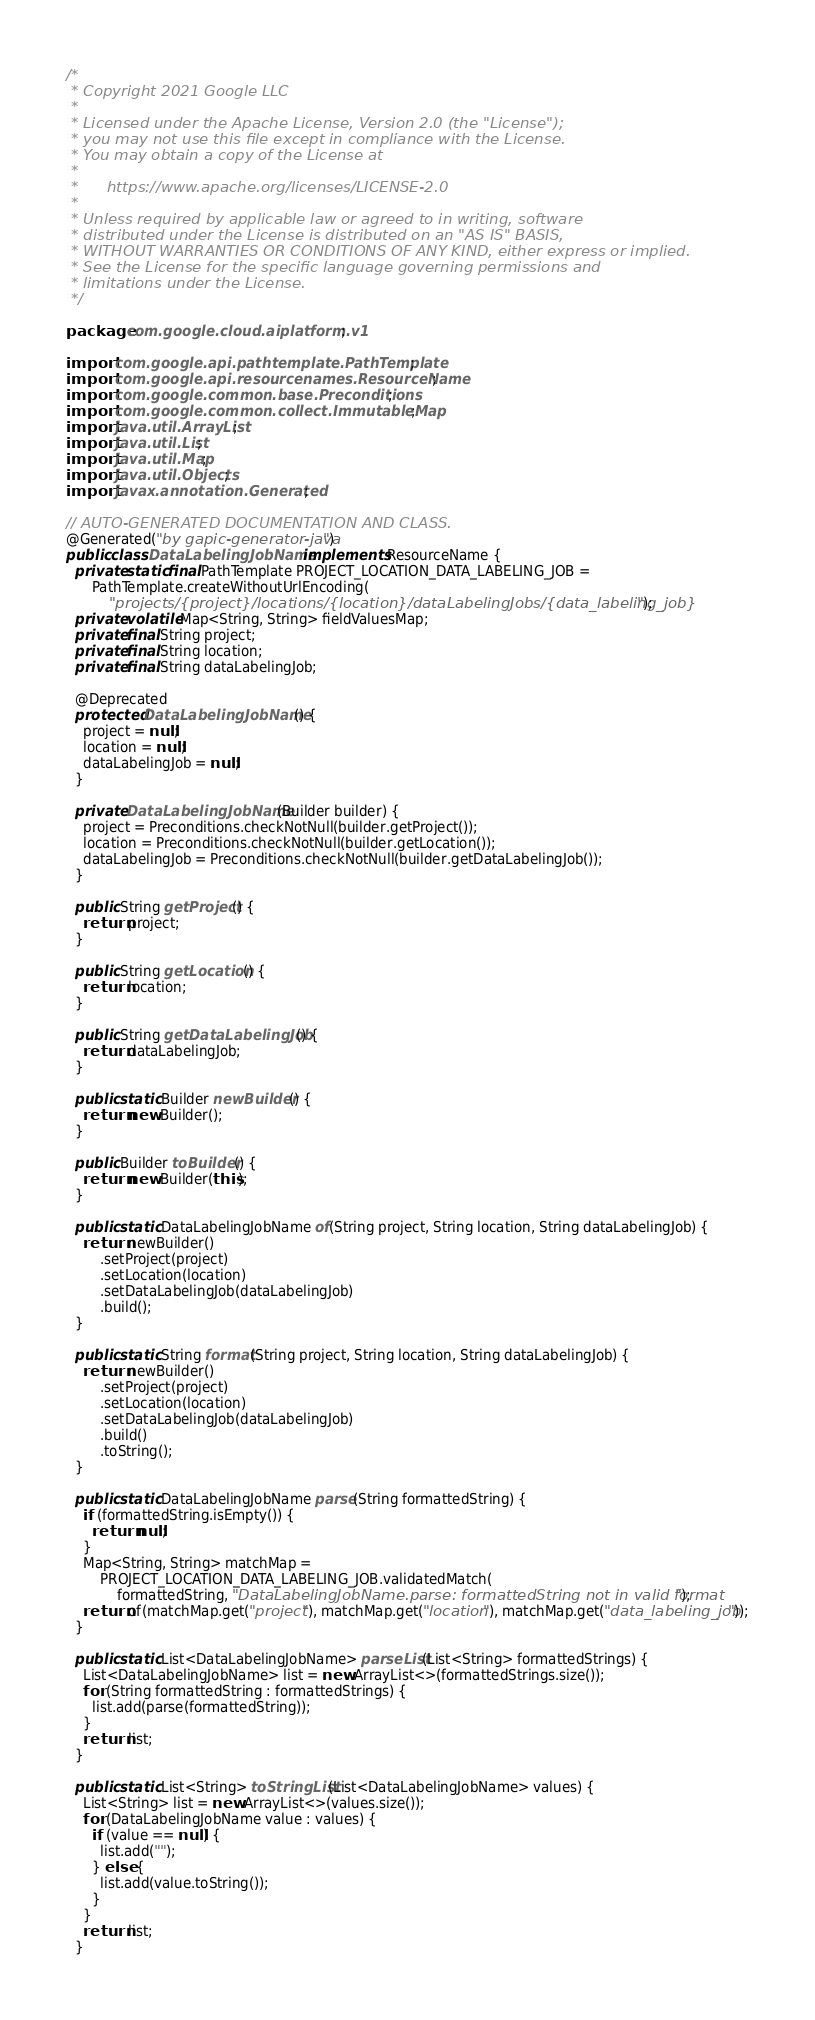Convert code to text. <code><loc_0><loc_0><loc_500><loc_500><_Java_>/*
 * Copyright 2021 Google LLC
 *
 * Licensed under the Apache License, Version 2.0 (the "License");
 * you may not use this file except in compliance with the License.
 * You may obtain a copy of the License at
 *
 *      https://www.apache.org/licenses/LICENSE-2.0
 *
 * Unless required by applicable law or agreed to in writing, software
 * distributed under the License is distributed on an "AS IS" BASIS,
 * WITHOUT WARRANTIES OR CONDITIONS OF ANY KIND, either express or implied.
 * See the License for the specific language governing permissions and
 * limitations under the License.
 */

package com.google.cloud.aiplatform.v1;

import com.google.api.pathtemplate.PathTemplate;
import com.google.api.resourcenames.ResourceName;
import com.google.common.base.Preconditions;
import com.google.common.collect.ImmutableMap;
import java.util.ArrayList;
import java.util.List;
import java.util.Map;
import java.util.Objects;
import javax.annotation.Generated;

// AUTO-GENERATED DOCUMENTATION AND CLASS.
@Generated("by gapic-generator-java")
public class DataLabelingJobName implements ResourceName {
  private static final PathTemplate PROJECT_LOCATION_DATA_LABELING_JOB =
      PathTemplate.createWithoutUrlEncoding(
          "projects/{project}/locations/{location}/dataLabelingJobs/{data_labeling_job}");
  private volatile Map<String, String> fieldValuesMap;
  private final String project;
  private final String location;
  private final String dataLabelingJob;

  @Deprecated
  protected DataLabelingJobName() {
    project = null;
    location = null;
    dataLabelingJob = null;
  }

  private DataLabelingJobName(Builder builder) {
    project = Preconditions.checkNotNull(builder.getProject());
    location = Preconditions.checkNotNull(builder.getLocation());
    dataLabelingJob = Preconditions.checkNotNull(builder.getDataLabelingJob());
  }

  public String getProject() {
    return project;
  }

  public String getLocation() {
    return location;
  }

  public String getDataLabelingJob() {
    return dataLabelingJob;
  }

  public static Builder newBuilder() {
    return new Builder();
  }

  public Builder toBuilder() {
    return new Builder(this);
  }

  public static DataLabelingJobName of(String project, String location, String dataLabelingJob) {
    return newBuilder()
        .setProject(project)
        .setLocation(location)
        .setDataLabelingJob(dataLabelingJob)
        .build();
  }

  public static String format(String project, String location, String dataLabelingJob) {
    return newBuilder()
        .setProject(project)
        .setLocation(location)
        .setDataLabelingJob(dataLabelingJob)
        .build()
        .toString();
  }

  public static DataLabelingJobName parse(String formattedString) {
    if (formattedString.isEmpty()) {
      return null;
    }
    Map<String, String> matchMap =
        PROJECT_LOCATION_DATA_LABELING_JOB.validatedMatch(
            formattedString, "DataLabelingJobName.parse: formattedString not in valid format");
    return of(matchMap.get("project"), matchMap.get("location"), matchMap.get("data_labeling_job"));
  }

  public static List<DataLabelingJobName> parseList(List<String> formattedStrings) {
    List<DataLabelingJobName> list = new ArrayList<>(formattedStrings.size());
    for (String formattedString : formattedStrings) {
      list.add(parse(formattedString));
    }
    return list;
  }

  public static List<String> toStringList(List<DataLabelingJobName> values) {
    List<String> list = new ArrayList<>(values.size());
    for (DataLabelingJobName value : values) {
      if (value == null) {
        list.add("");
      } else {
        list.add(value.toString());
      }
    }
    return list;
  }
</code> 